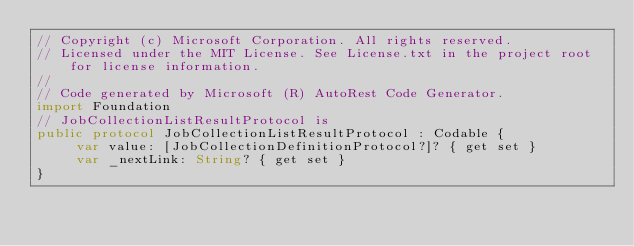Convert code to text. <code><loc_0><loc_0><loc_500><loc_500><_Swift_>// Copyright (c) Microsoft Corporation. All rights reserved.
// Licensed under the MIT License. See License.txt in the project root for license information.
//
// Code generated by Microsoft (R) AutoRest Code Generator.
import Foundation
// JobCollectionListResultProtocol is
public protocol JobCollectionListResultProtocol : Codable {
     var value: [JobCollectionDefinitionProtocol?]? { get set }
     var _nextLink: String? { get set }
}
</code> 